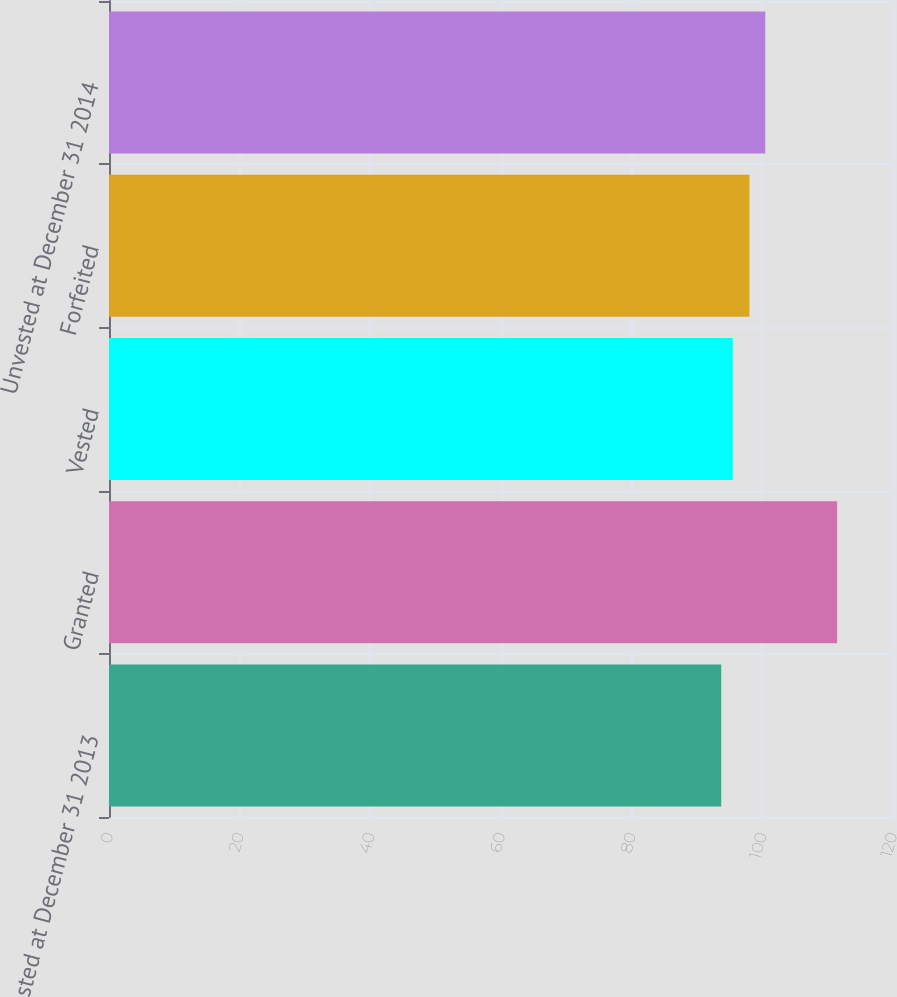<chart> <loc_0><loc_0><loc_500><loc_500><bar_chart><fcel>Unvested at December 31 2013<fcel>Granted<fcel>Vested<fcel>Forfeited<fcel>Unvested at December 31 2014<nl><fcel>93.71<fcel>111.45<fcel>95.48<fcel>98.02<fcel>100.45<nl></chart> 